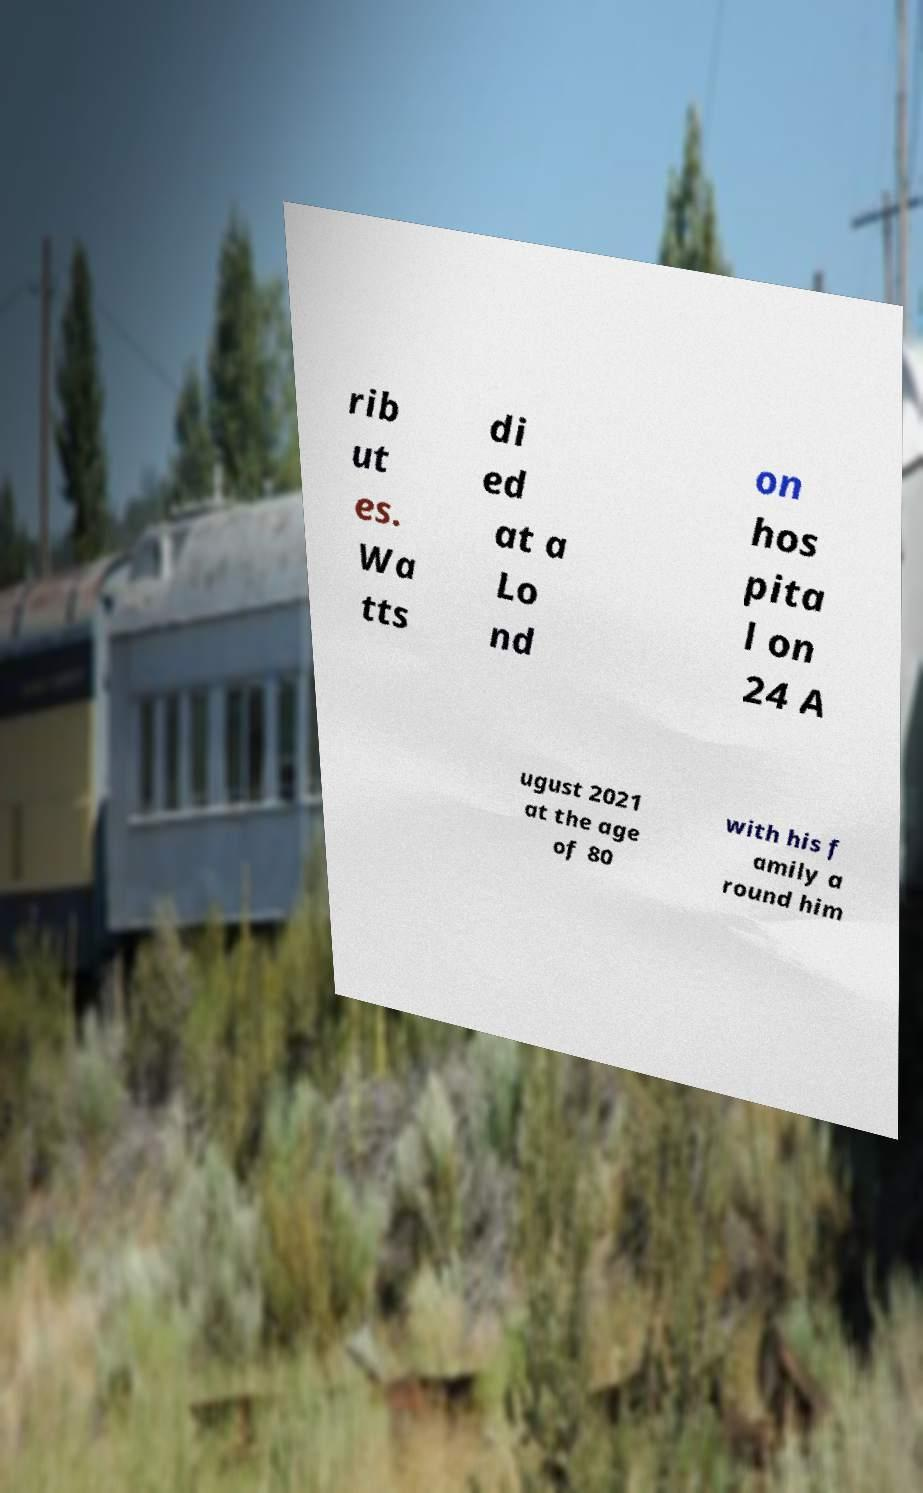There's text embedded in this image that I need extracted. Can you transcribe it verbatim? rib ut es. Wa tts di ed at a Lo nd on hos pita l on 24 A ugust 2021 at the age of 80 with his f amily a round him 